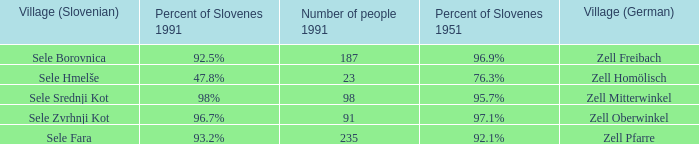Provide me with the name of all the village (German) that are part of the village (Slovenian) with sele srednji kot.  Zell Mitterwinkel. 